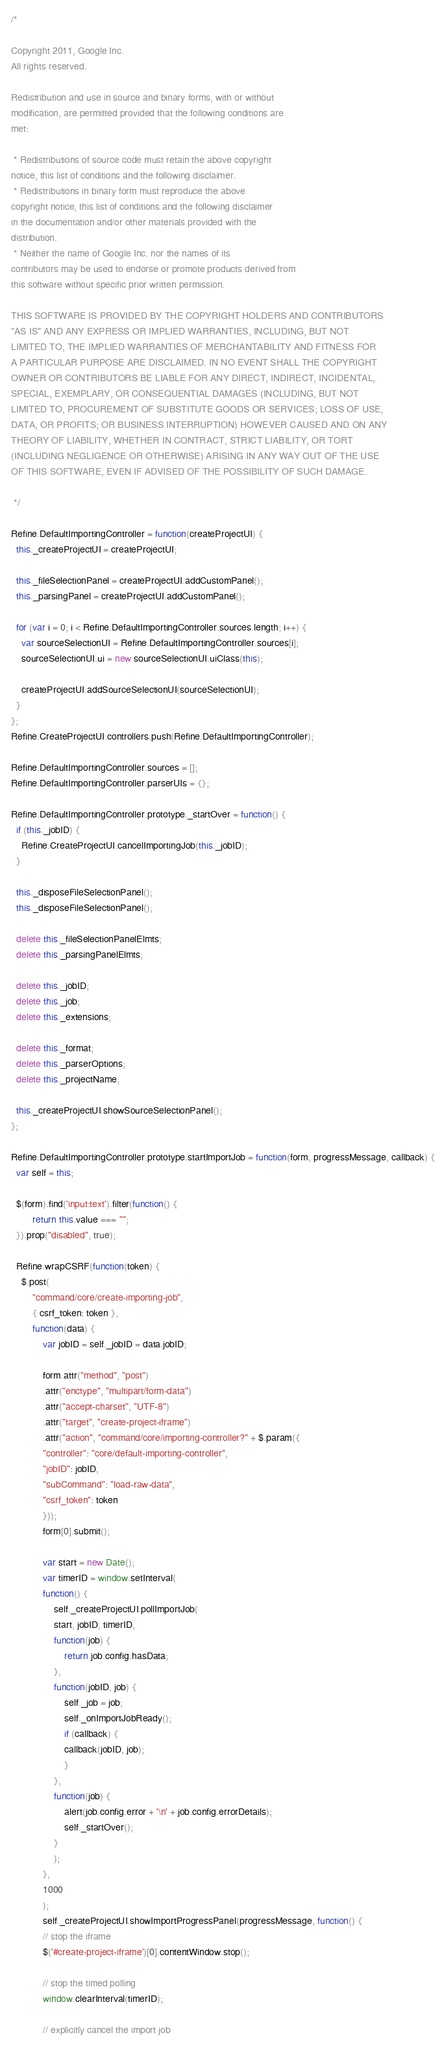<code> <loc_0><loc_0><loc_500><loc_500><_JavaScript_>/*

Copyright 2011, Google Inc.
All rights reserved.

Redistribution and use in source and binary forms, with or without
modification, are permitted provided that the following conditions are
met:

 * Redistributions of source code must retain the above copyright
notice, this list of conditions and the following disclaimer.
 * Redistributions in binary form must reproduce the above
copyright notice, this list of conditions and the following disclaimer
in the documentation and/or other materials provided with the
distribution.
 * Neither the name of Google Inc. nor the names of its
contributors may be used to endorse or promote products derived from
this software without specific prior written permission.

THIS SOFTWARE IS PROVIDED BY THE COPYRIGHT HOLDERS AND CONTRIBUTORS
"AS IS" AND ANY EXPRESS OR IMPLIED WARRANTIES, INCLUDING, BUT NOT
LIMITED TO, THE IMPLIED WARRANTIES OF MERCHANTABILITY AND FITNESS FOR
A PARTICULAR PURPOSE ARE DISCLAIMED. IN NO EVENT SHALL THE COPYRIGHT
OWNER OR CONTRIBUTORS BE LIABLE FOR ANY DIRECT, INDIRECT, INCIDENTAL,
SPECIAL, EXEMPLARY, OR CONSEQUENTIAL DAMAGES (INCLUDING, BUT NOT
LIMITED TO, PROCUREMENT OF SUBSTITUTE GOODS OR SERVICES; LOSS OF USE,           
DATA, OR PROFITS; OR BUSINESS INTERRUPTION) HOWEVER CAUSED AND ON ANY           
THEORY OF LIABILITY, WHETHER IN CONTRACT, STRICT LIABILITY, OR TORT
(INCLUDING NEGLIGENCE OR OTHERWISE) ARISING IN ANY WAY OUT OF THE USE
OF THIS SOFTWARE, EVEN IF ADVISED OF THE POSSIBILITY OF SUCH DAMAGE.

 */

Refine.DefaultImportingController = function(createProjectUI) {
  this._createProjectUI = createProjectUI;

  this._fileSelectionPanel = createProjectUI.addCustomPanel();
  this._parsingPanel = createProjectUI.addCustomPanel();

  for (var i = 0; i < Refine.DefaultImportingController.sources.length; i++) {
    var sourceSelectionUI = Refine.DefaultImportingController.sources[i];
    sourceSelectionUI.ui = new sourceSelectionUI.uiClass(this);

    createProjectUI.addSourceSelectionUI(sourceSelectionUI);
  }
};
Refine.CreateProjectUI.controllers.push(Refine.DefaultImportingController);

Refine.DefaultImportingController.sources = [];
Refine.DefaultImportingController.parserUIs = {};

Refine.DefaultImportingController.prototype._startOver = function() {
  if (this._jobID) {
    Refine.CreateProjectUI.cancelImportingJob(this._jobID);
  }
  
  this._disposeFileSelectionPanel();
  this._disposeFileSelectionPanel();

  delete this._fileSelectionPanelElmts;
  delete this._parsingPanelElmts;

  delete this._jobID;
  delete this._job;
  delete this._extensions;

  delete this._format;
  delete this._parserOptions;
  delete this._projectName;

  this._createProjectUI.showSourceSelectionPanel();
};

Refine.DefaultImportingController.prototype.startImportJob = function(form, progressMessage, callback) {
  var self = this;
  
  $(form).find('input:text').filter(function() { 
		return this.value === ""; 
  }).prop("disabled", true);
  
  Refine.wrapCSRF(function(token) {
    $.post(
        "command/core/create-importing-job",
        { csrf_token: token },
        function(data) {
            var jobID = self._jobID = data.jobID;

            form.attr("method", "post")
            .attr("enctype", "multipart/form-data")
            .attr("accept-charset", "UTF-8")
            .attr("target", "create-project-iframe")
            .attr("action", "command/core/importing-controller?" + $.param({
            "controller": "core/default-importing-controller",
            "jobID": jobID,
            "subCommand": "load-raw-data",
            "csrf_token": token
            }));
            form[0].submit();

            var start = new Date();
            var timerID = window.setInterval(
            function() {
                self._createProjectUI.pollImportJob(
                start, jobID, timerID,
                function(job) {
                    return job.config.hasData;
                },
                function(jobID, job) {
                    self._job = job;
                    self._onImportJobReady();
                    if (callback) {
                    callback(jobID, job);
                    }
                },
                function(job) {
                    alert(job.config.error + '\n' + job.config.errorDetails);
                    self._startOver();
                }
                );
            },
            1000
            );
            self._createProjectUI.showImportProgressPanel(progressMessage, function() {
            // stop the iframe
            $('#create-project-iframe')[0].contentWindow.stop();

            // stop the timed polling
            window.clearInterval(timerID);

            // explicitly cancel the import job</code> 